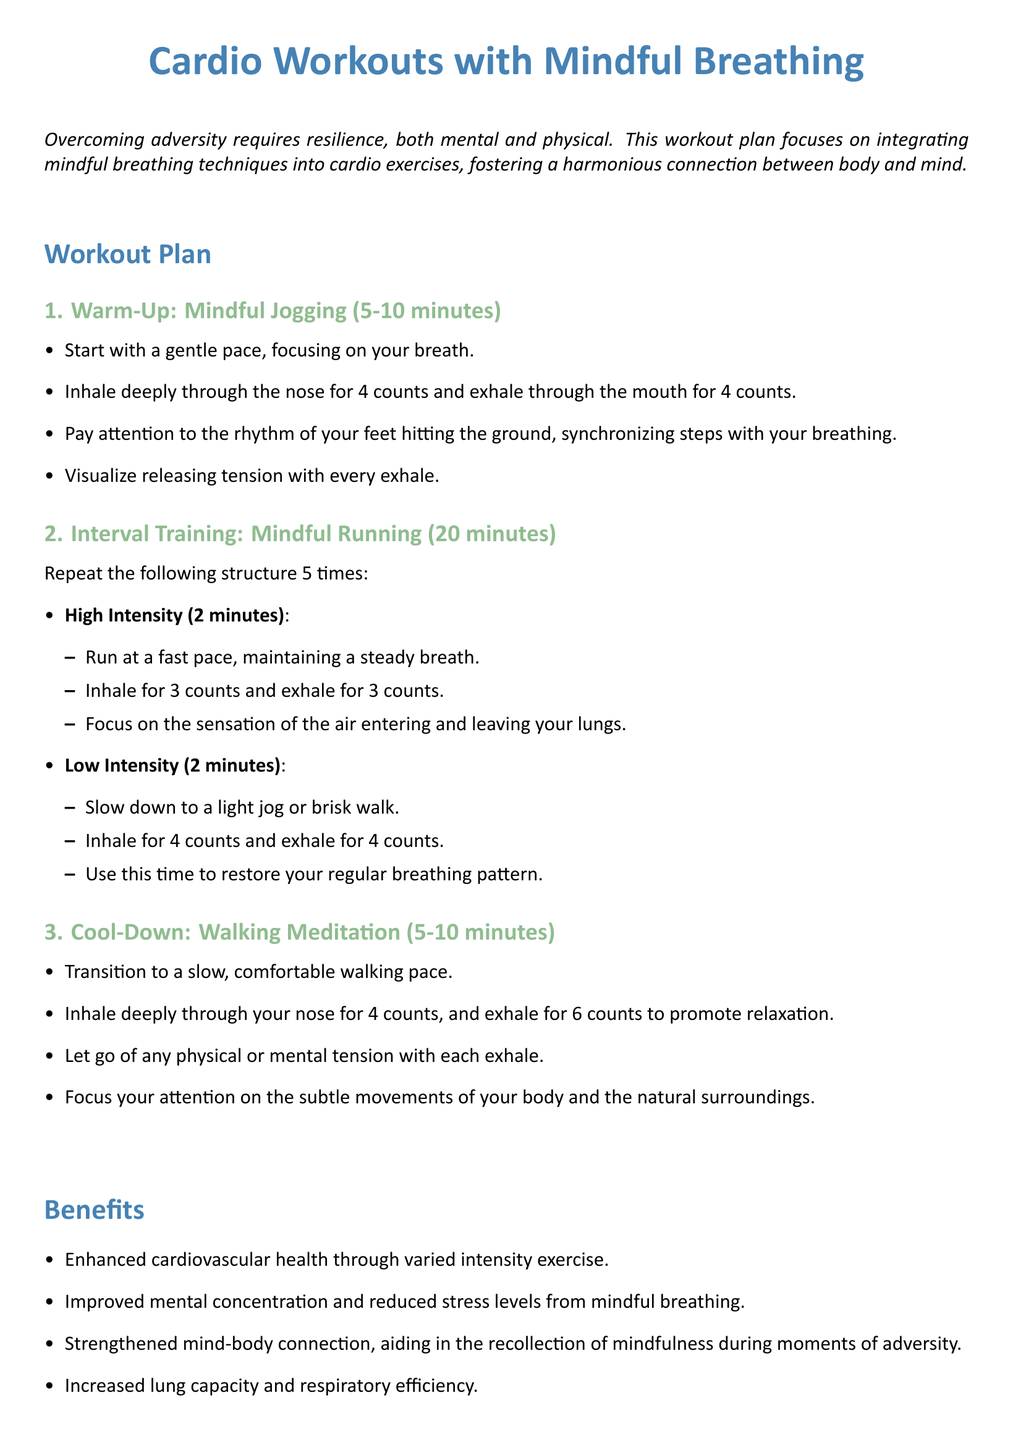What is the duration of the Warm-Up section? The Warm-Up section is specified to last between 5 to 10 minutes.
Answer: 5-10 minutes How many times should the interval training cycle be repeated? The workout plan states that the interval training structure should be repeated 5 times.
Answer: 5 times What technique is used during the Cool-Down? The Cool-Down section incorporates a Walking Meditation technique.
Answer: Walking Meditation What is the breathing pattern during high-intensity running? During high-intensity running, the recommended breathing pattern is to inhale for 3 counts and exhale for 3 counts.
Answer: Inhale for 3 counts and exhale for 3 counts What is one benefit of incorporating mindful breathing? One benefit mentioned is improved mental concentration and reduced stress levels from mindful breathing.
Answer: Improved mental concentration What kind of exercise is suggested for recovery during low-intensity intervals? The suggested exercise during low-intensity intervals is a light jog or brisk walk.
Answer: Light jog or brisk walk What visual element is used to highlight section titles? The section titles are highlighted using color, specifically mindful blue for the main sections.
Answer: Mindful blue What is the primary focus of this workout plan? The primary focus of this workout plan is integrating mindful breathing techniques into cardio exercises.
Answer: Mindful breathing techniques 